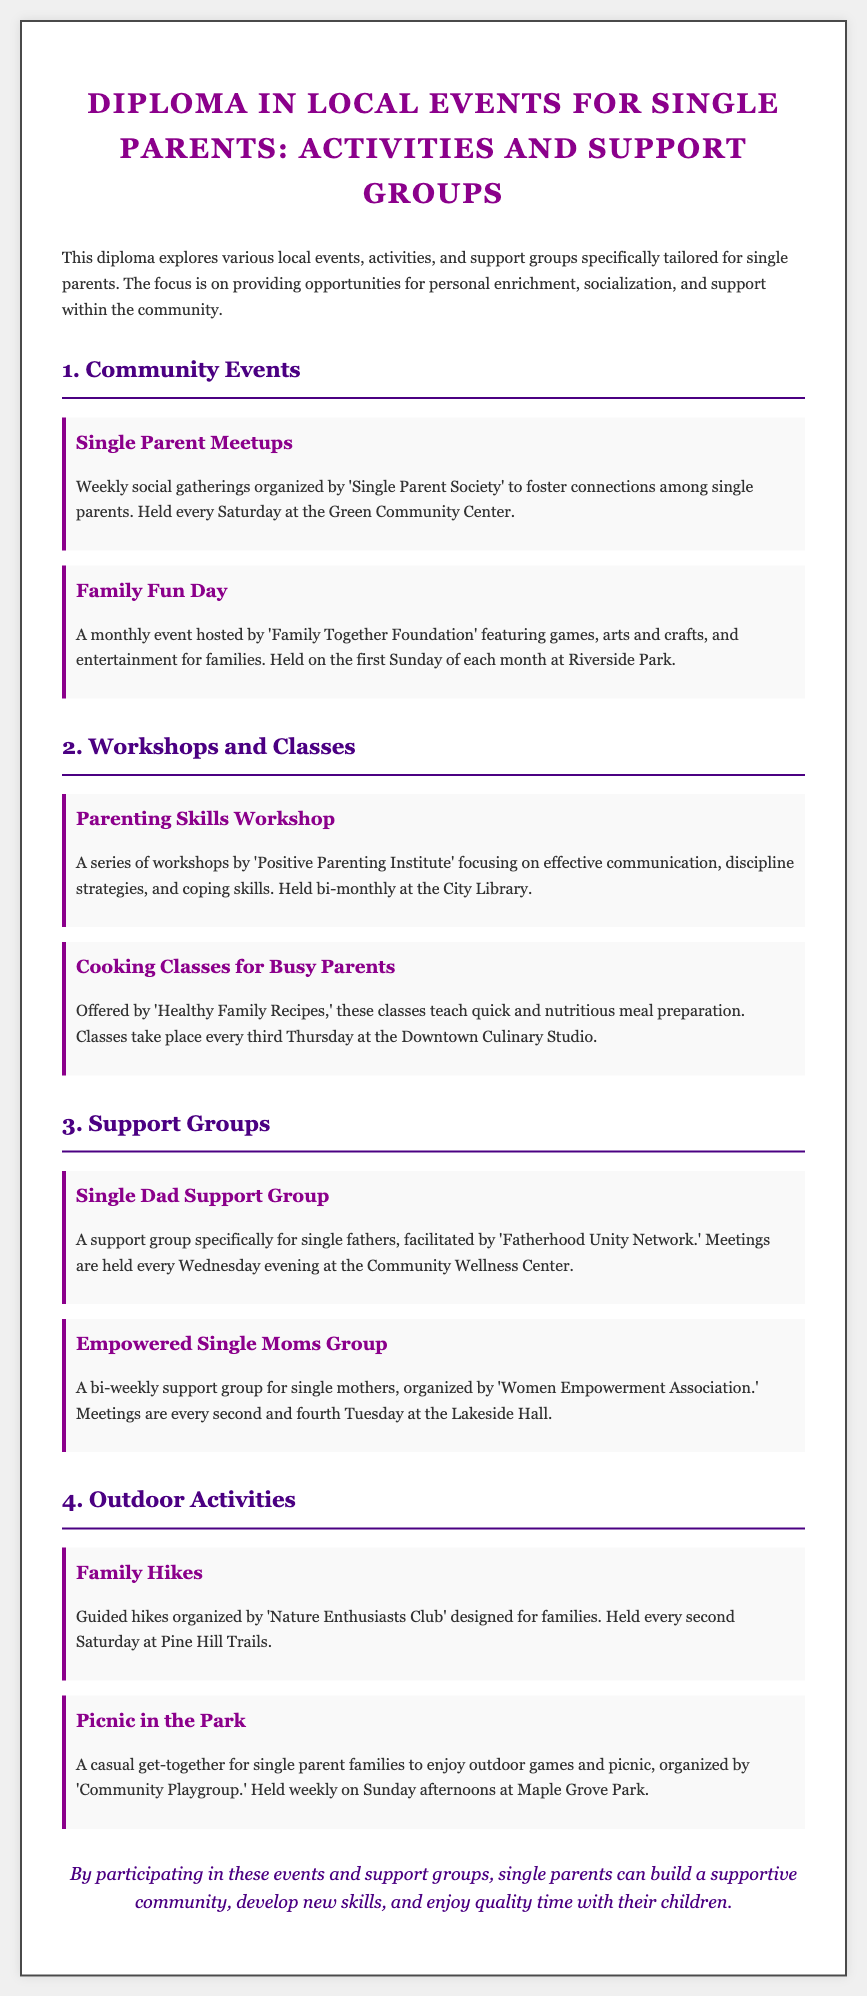What is the title of the diploma? The title of the diploma is clearly stated at the top of the document.
Answer: Diploma in Local Events for Single Parents: Activities and Support Groups How often are Single Parent Meetups held? The frequency of the meetups is mentioned in the event description.
Answer: Every Saturday Which organization hosts the Family Fun Day? The event description includes the name of the organization behind the Family Fun Day.
Answer: Family Together Foundation When is the Cooking Classes for Busy Parents scheduled? The document specifies the timing for the cooking classes.
Answer: Every third Thursday What is the name of the support group specifically for single fathers? The document lists the support group tailored to single fathers.
Answer: Single Dad Support Group What type of activities does the Nature Enthusiasts Club organize? The description provides insight into the type of events organized by the Nature Enthusiasts Club.
Answer: Guided hikes Which venue hosts the Parenting Skills Workshop? The document mentions the location of the workshop.
Answer: City Library How often do the Empowered Single Moms Group meetings occur? The frequency of the meetings is explicitly stated in the document.
Answer: Bi-weekly What is the main purpose of these events and support groups? The conclusion summarizes the overall aim of the events mentioned in the document.
Answer: Build a supportive community 